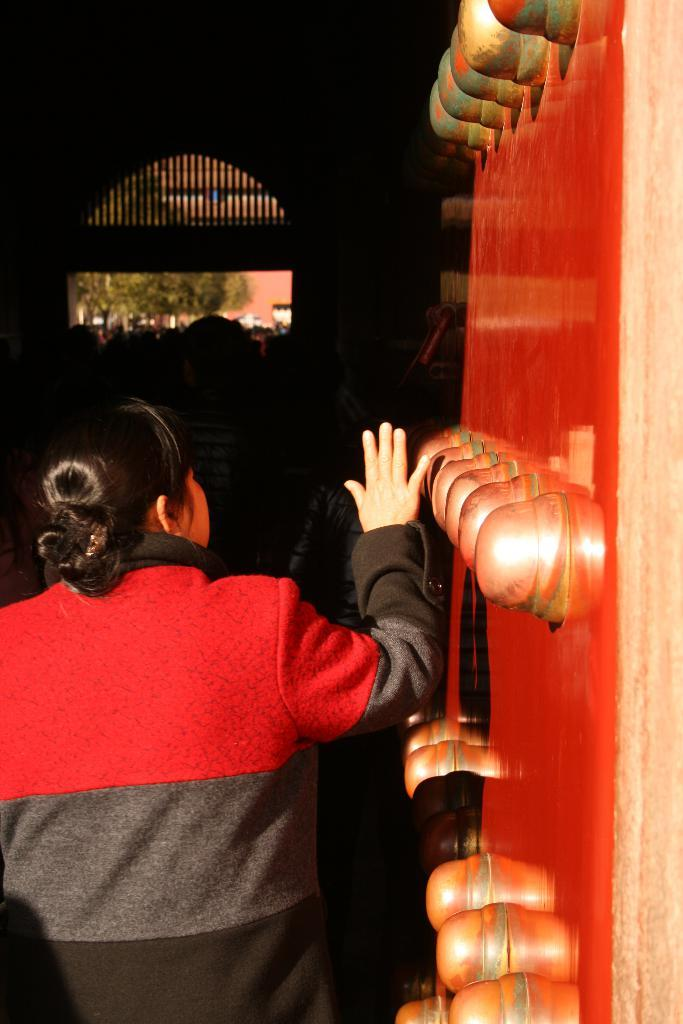What is located in the center of the image? There is a wall in the center of the image. Who or what is positioned in front of the wall? There is a person standing in the center of the image. What can be seen in the distance behind the person? There are trees, a building, and a fence in the background of the image. Are there any other people visible in the image? Yes, there are people standing in the background of the image. How many muscles can be seen flexing in the image? There is no indication of muscles flexing in the image; it features a wall, a person, and various background elements. 